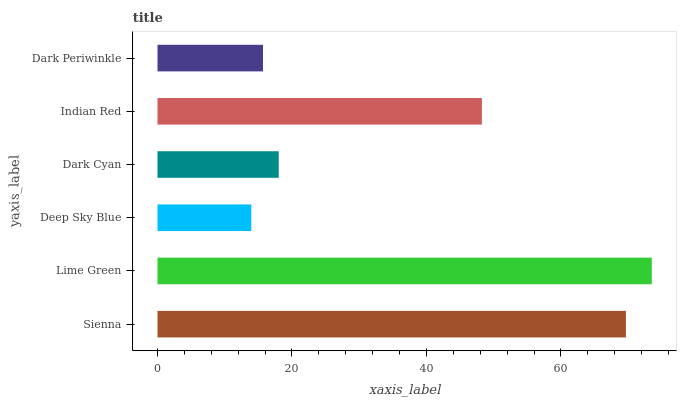Is Deep Sky Blue the minimum?
Answer yes or no. Yes. Is Lime Green the maximum?
Answer yes or no. Yes. Is Lime Green the minimum?
Answer yes or no. No. Is Deep Sky Blue the maximum?
Answer yes or no. No. Is Lime Green greater than Deep Sky Blue?
Answer yes or no. Yes. Is Deep Sky Blue less than Lime Green?
Answer yes or no. Yes. Is Deep Sky Blue greater than Lime Green?
Answer yes or no. No. Is Lime Green less than Deep Sky Blue?
Answer yes or no. No. Is Indian Red the high median?
Answer yes or no. Yes. Is Dark Cyan the low median?
Answer yes or no. Yes. Is Sienna the high median?
Answer yes or no. No. Is Indian Red the low median?
Answer yes or no. No. 